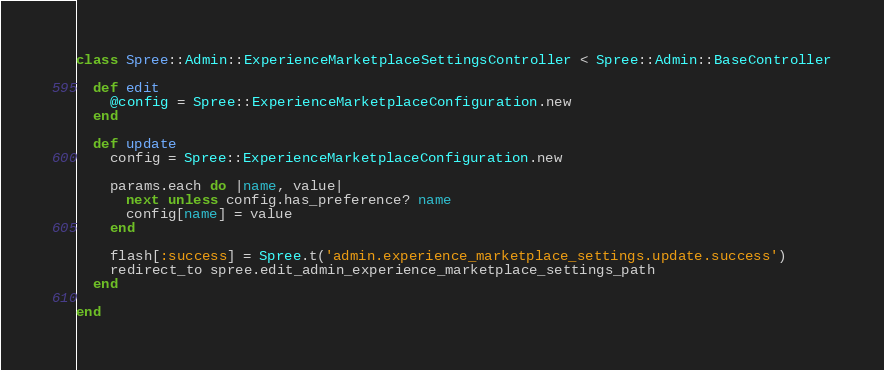<code> <loc_0><loc_0><loc_500><loc_500><_Ruby_>class Spree::Admin::ExperienceMarketplaceSettingsController < Spree::Admin::BaseController

  def edit
    @config = Spree::ExperienceMarketplaceConfiguration.new
  end

  def update
    config = Spree::ExperienceMarketplaceConfiguration.new

    params.each do |name, value|
      next unless config.has_preference? name
      config[name] = value
    end

    flash[:success] = Spree.t('admin.experience_marketplace_settings.update.success')
    redirect_to spree.edit_admin_experience_marketplace_settings_path
  end

end</code> 